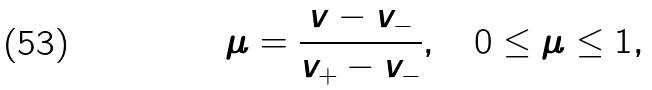Convert formula to latex. <formula><loc_0><loc_0><loc_500><loc_500>\mu = \frac { v - v _ { - } } { v _ { + } - v _ { - } } , \quad 0 \leq \mu \leq 1 ,</formula> 